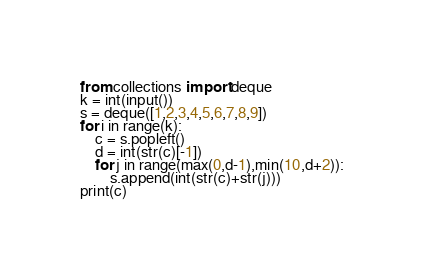Convert code to text. <code><loc_0><loc_0><loc_500><loc_500><_Python_>from collections import deque
k = int(input())
s = deque([1,2,3,4,5,6,7,8,9])
for i in range(k):
    c = s.popleft()
    d = int(str(c)[-1])
    for j in range(max(0,d-1),min(10,d+2)):
        s.append(int(str(c)+str(j)))
print(c)</code> 